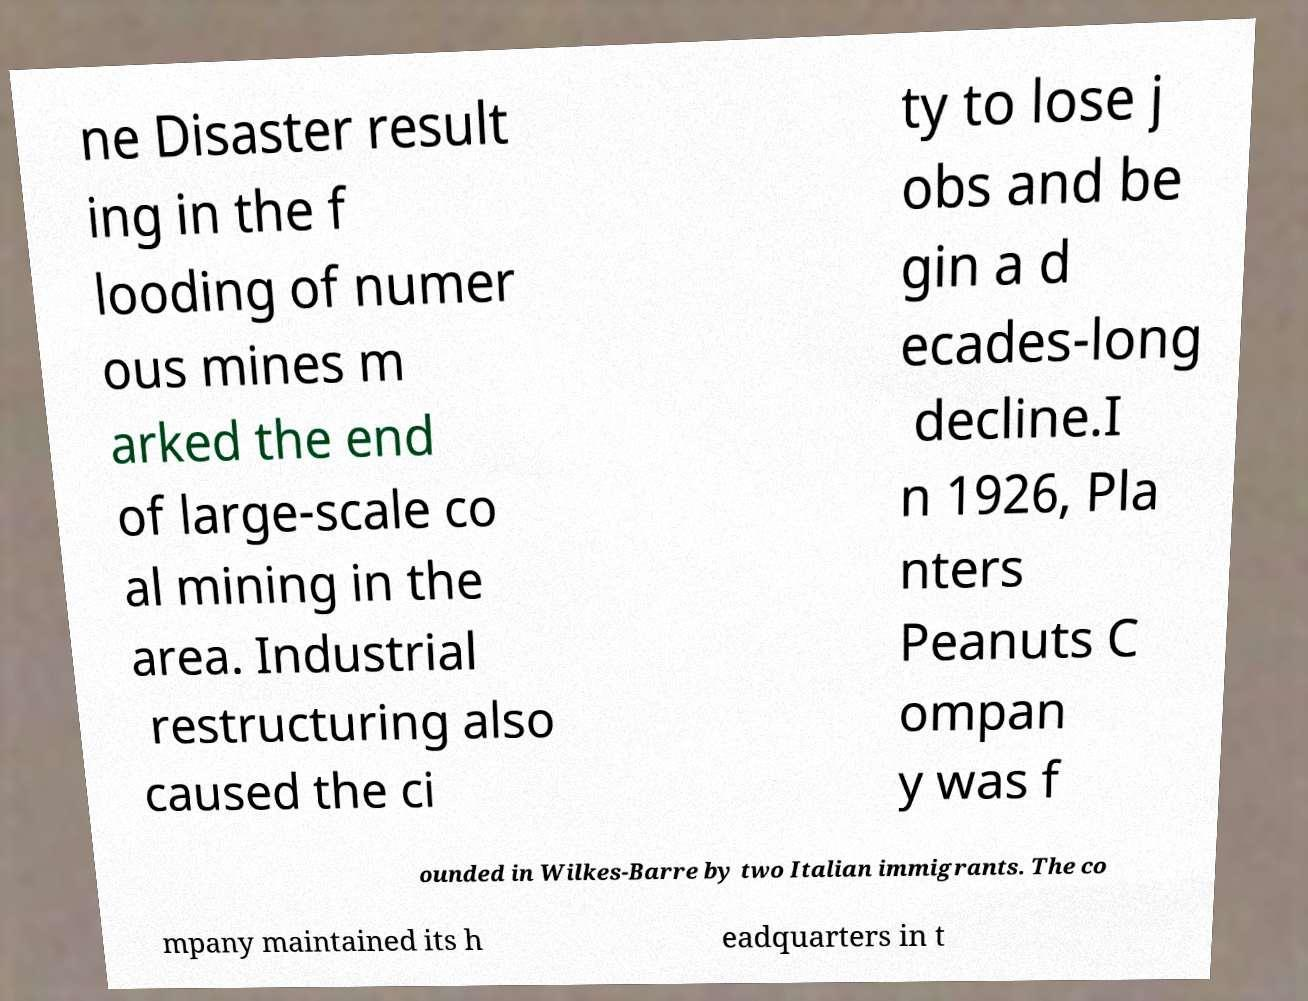Could you extract and type out the text from this image? ne Disaster result ing in the f looding of numer ous mines m arked the end of large-scale co al mining in the area. Industrial restructuring also caused the ci ty to lose j obs and be gin a d ecades-long decline.I n 1926, Pla nters Peanuts C ompan y was f ounded in Wilkes-Barre by two Italian immigrants. The co mpany maintained its h eadquarters in t 